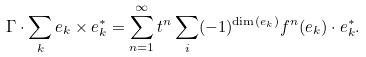Convert formula to latex. <formula><loc_0><loc_0><loc_500><loc_500>\Gamma \cdot \sum _ { k } e _ { k } \times e _ { k } ^ { * } = \sum _ { n = 1 } ^ { \infty } t ^ { n } \sum _ { i } ( - 1 ) ^ { \dim ( e _ { k } ) } f ^ { n } ( e _ { k } ) \cdot e _ { k } ^ { * } .</formula> 